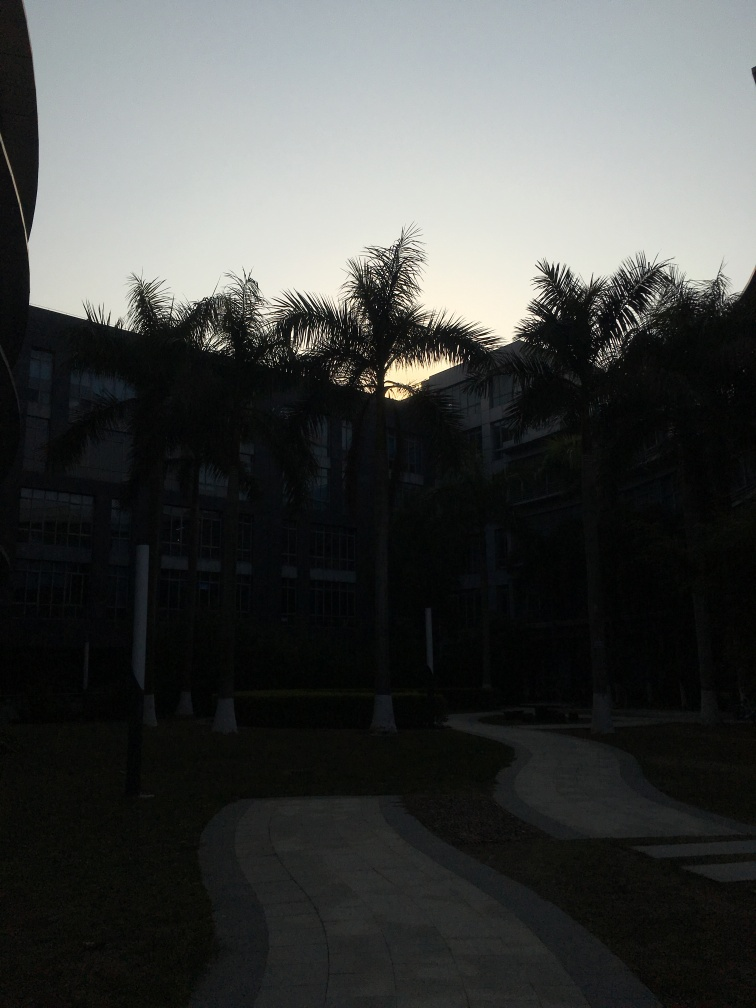What time of day does it appear to be in this image? It seems to be either dawn or dusk, as suggested by the low level of natural light and the position of what appears to be the sun near the horizon, behind the building. Can you describe the ambiance or atmosphere of the location shown? The atmosphere appears serene, with a gentle tranquil quality that often accompanies the early morning or evening hours. The winding path and well-maintained grass suggest a peaceful outdoor area, likely part of a campus or residential complex. 